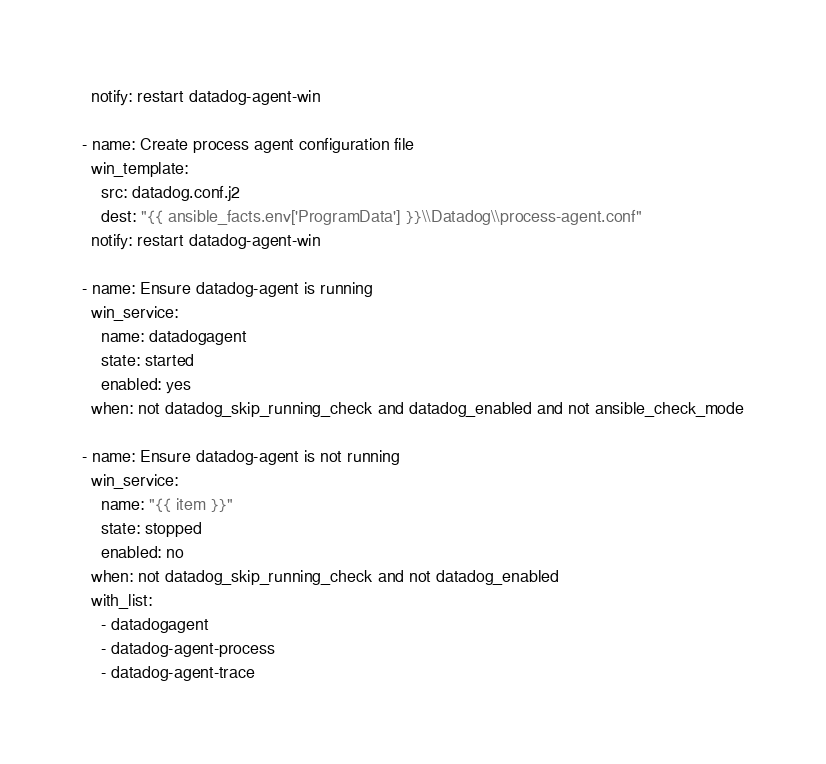<code> <loc_0><loc_0><loc_500><loc_500><_YAML_>  notify: restart datadog-agent-win

- name: Create process agent configuration file
  win_template:
    src: datadog.conf.j2
    dest: "{{ ansible_facts.env['ProgramData'] }}\\Datadog\\process-agent.conf"
  notify: restart datadog-agent-win

- name: Ensure datadog-agent is running
  win_service:
    name: datadogagent
    state: started
    enabled: yes
  when: not datadog_skip_running_check and datadog_enabled and not ansible_check_mode

- name: Ensure datadog-agent is not running
  win_service:
    name: "{{ item }}"
    state: stopped
    enabled: no
  when: not datadog_skip_running_check and not datadog_enabled
  with_list:
    - datadogagent
    - datadog-agent-process
    - datadog-agent-trace
</code> 